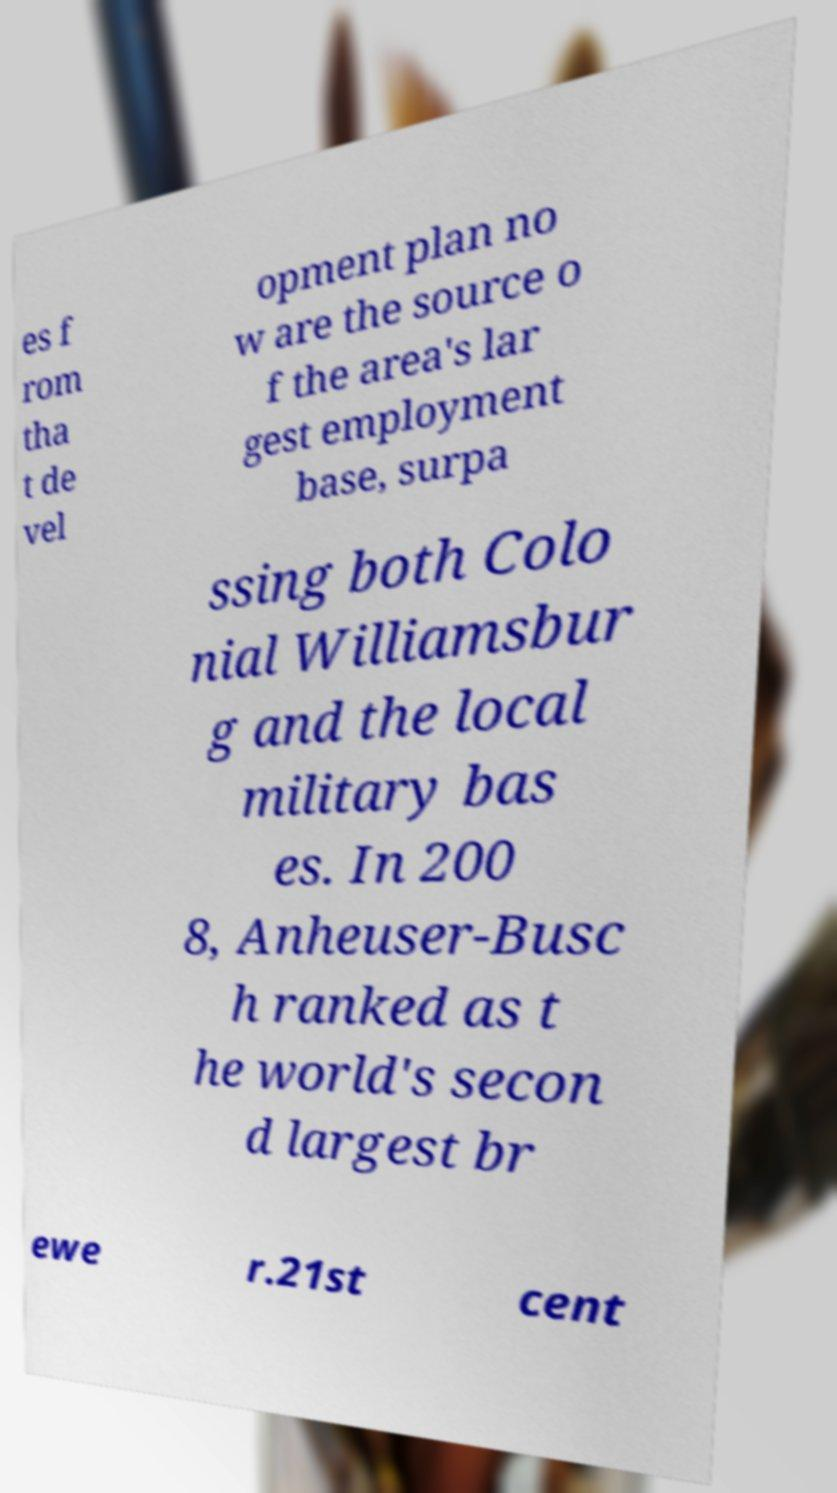What messages or text are displayed in this image? I need them in a readable, typed format. es f rom tha t de vel opment plan no w are the source o f the area's lar gest employment base, surpa ssing both Colo nial Williamsbur g and the local military bas es. In 200 8, Anheuser-Busc h ranked as t he world's secon d largest br ewe r.21st cent 